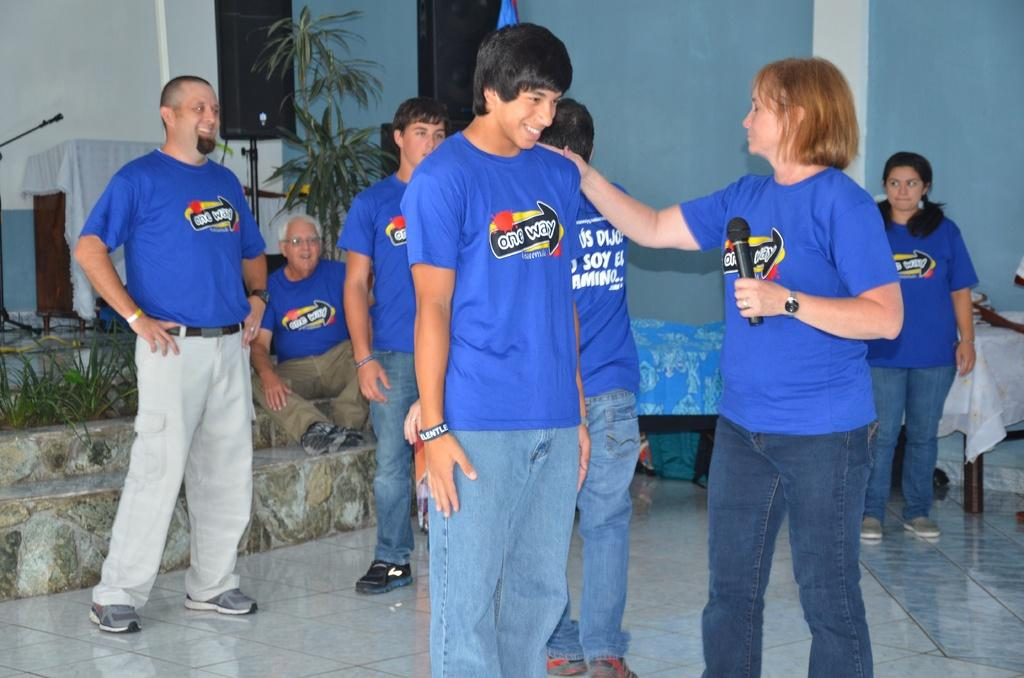Provide a one-sentence caption for the provided image. A woman is touching another person's shoulder and both are wearing shirts that say one way on them. 